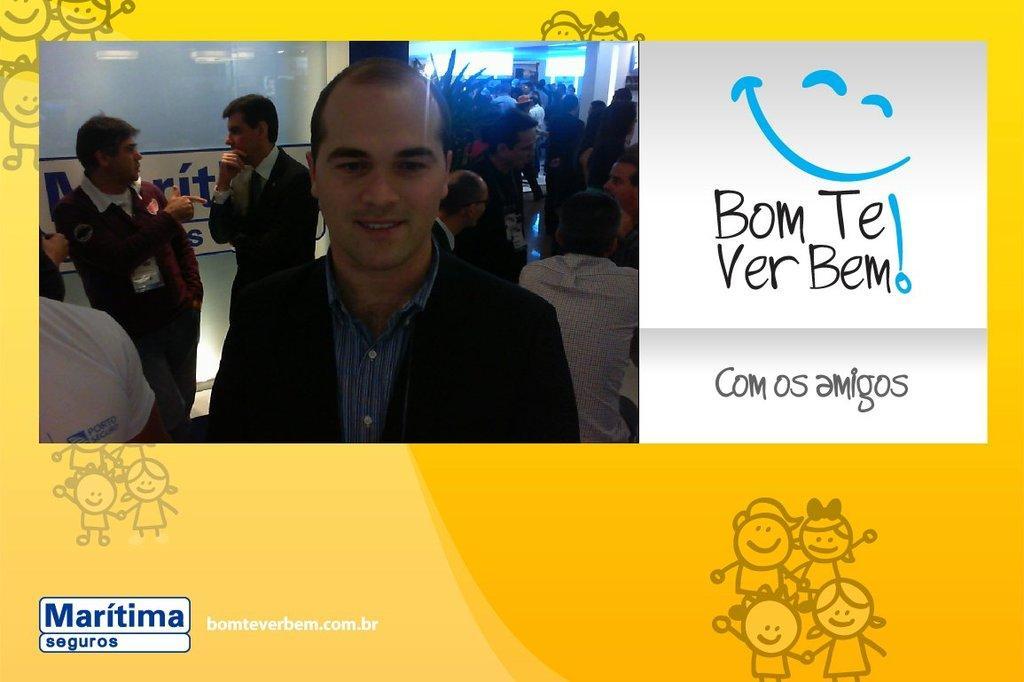Could you give a brief overview of what you see in this image? This is an edited picture. I can see a photo of group of people standing, there are words and symbols. 